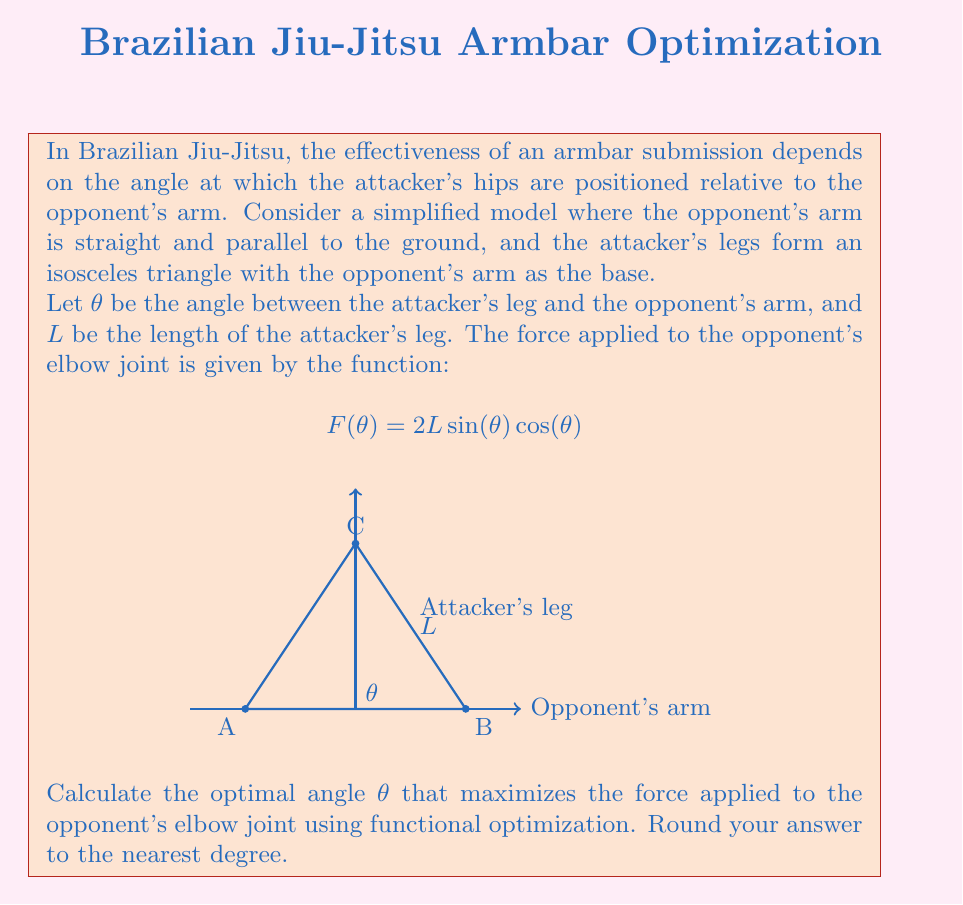What is the answer to this math problem? To find the optimal angle $\theta$ that maximizes the force $F(\theta)$, we need to follow these steps:

1) First, we need to find the derivative of $F(\theta)$ with respect to $\theta$:

   $$\frac{d}{d\theta}F(\theta) = 2L(\cos^2(\theta) - \sin^2(\theta))$$

2) To find the maximum, we set this derivative equal to zero:

   $$2L(\cos^2(\theta) - \sin^2(\theta)) = 0$$

3) Simplify:

   $$\cos^2(\theta) - \sin^2(\theta) = 0$$

4) Recall the trigonometric identity $\cos^2(\theta) - \sin^2(\theta) = \cos(2\theta)$:

   $$\cos(2\theta) = 0$$

5) Solve for $\theta$:

   $$2\theta = \frac{\pi}{2} \text{ or } \frac{3\pi}{2}$$

   $$\theta = \frac{\pi}{4} \text{ or } \frac{3\pi}{4}$$

6) Since we're looking for the maximum (not minimum), and the force is positive in the first quadrant, we choose:

   $$\theta = \frac{\pi}{4}$$

7) Convert to degrees:

   $$\theta = \frac{\pi}{4} \cdot \frac{180°}{\pi} = 45°$$

Therefore, the optimal angle for maximizing the force in this armbar model is 45°.
Answer: 45° 